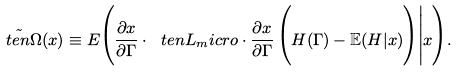<formula> <loc_0><loc_0><loc_500><loc_500>\tilde { \ t e n { \Omega } } ( x ) \equiv E \Big ( \frac { \partial x } { \partial \Gamma } \cdot \ t e n { L } _ { m } i c r o \cdot \frac { \partial x } { \partial \Gamma } \, \Big ( H ( \Gamma ) - \mathbb { E } ( H | x ) \Big ) \Big | x \Big ) .</formula> 